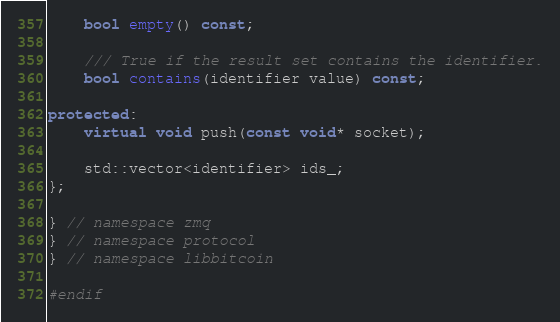Convert code to text. <code><loc_0><loc_0><loc_500><loc_500><_C++_>    bool empty() const;

    /// True if the result set contains the identifier.
    bool contains(identifier value) const;

protected:
    virtual void push(const void* socket);

    std::vector<identifier> ids_;
};

} // namespace zmq
} // namespace protocol
} // namespace libbitcoin

#endif
</code> 